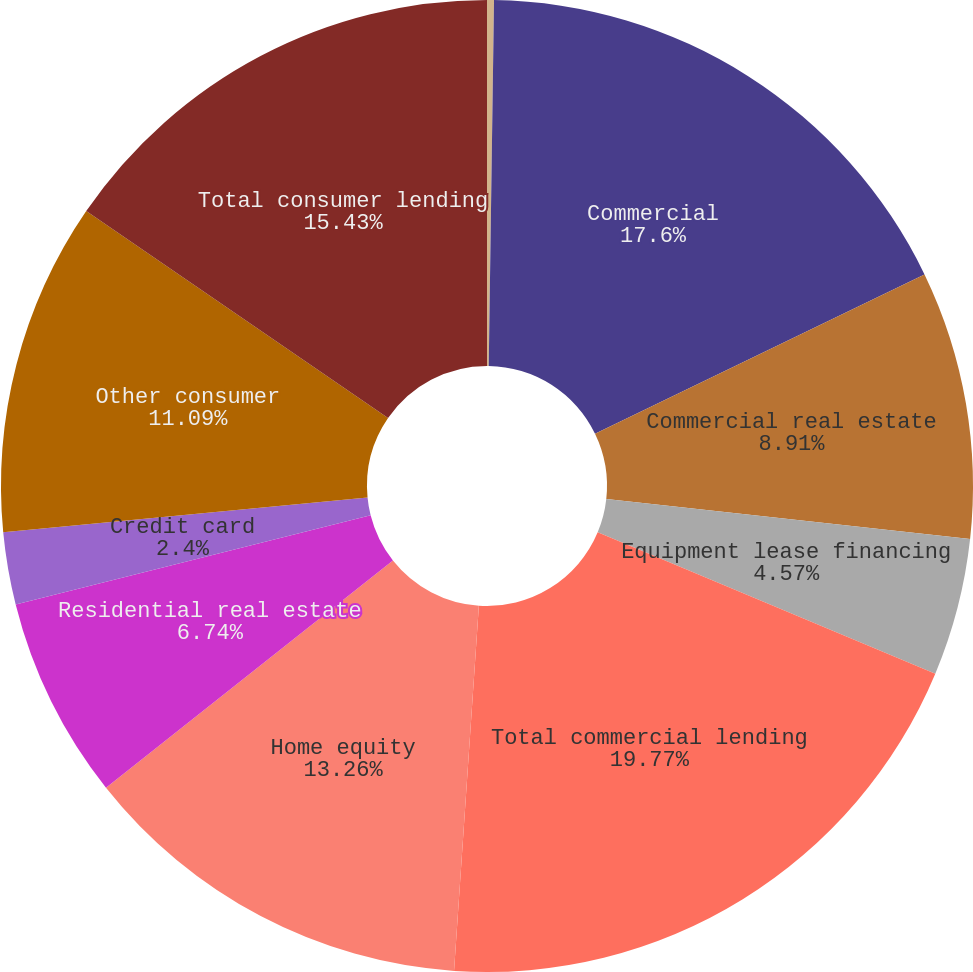Convert chart. <chart><loc_0><loc_0><loc_500><loc_500><pie_chart><fcel>December 31 - in millions<fcel>Commercial<fcel>Commercial real estate<fcel>Equipment lease financing<fcel>Total commercial lending<fcel>Home equity<fcel>Residential real estate<fcel>Credit card<fcel>Other consumer<fcel>Total consumer lending<nl><fcel>0.23%<fcel>17.6%<fcel>8.91%<fcel>4.57%<fcel>19.77%<fcel>13.26%<fcel>6.74%<fcel>2.4%<fcel>11.09%<fcel>15.43%<nl></chart> 